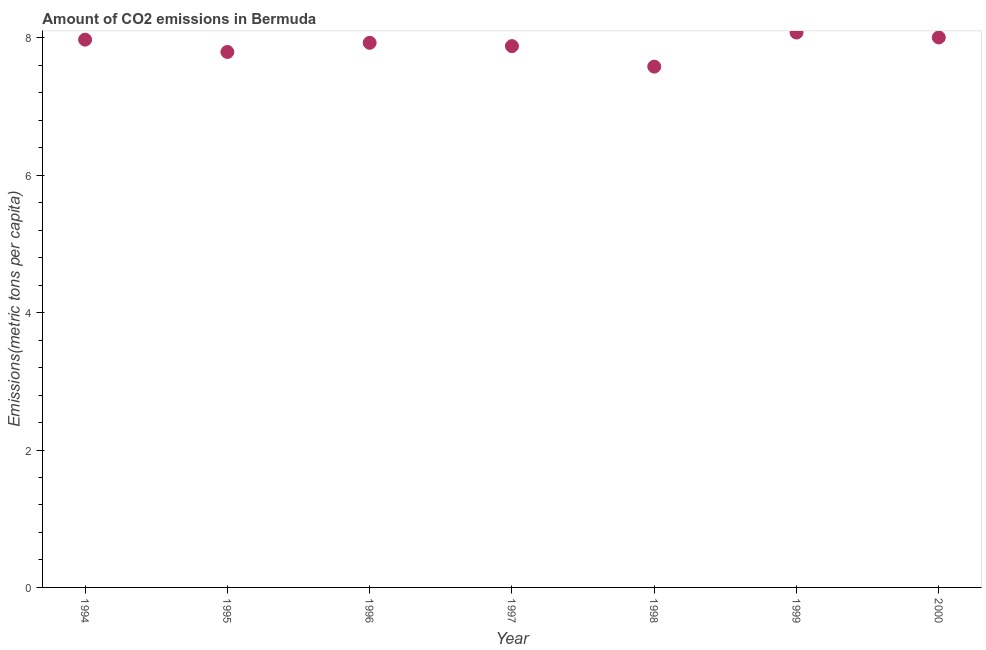What is the amount of co2 emissions in 1996?
Your response must be concise. 7.93. Across all years, what is the maximum amount of co2 emissions?
Provide a short and direct response. 8.08. Across all years, what is the minimum amount of co2 emissions?
Provide a succinct answer. 7.58. In which year was the amount of co2 emissions maximum?
Make the answer very short. 1999. What is the sum of the amount of co2 emissions?
Offer a terse response. 55.24. What is the difference between the amount of co2 emissions in 1998 and 2000?
Provide a succinct answer. -0.42. What is the average amount of co2 emissions per year?
Provide a succinct answer. 7.89. What is the median amount of co2 emissions?
Make the answer very short. 7.93. What is the ratio of the amount of co2 emissions in 1995 to that in 2000?
Keep it short and to the point. 0.97. What is the difference between the highest and the second highest amount of co2 emissions?
Your response must be concise. 0.07. Is the sum of the amount of co2 emissions in 1996 and 2000 greater than the maximum amount of co2 emissions across all years?
Give a very brief answer. Yes. What is the difference between the highest and the lowest amount of co2 emissions?
Keep it short and to the point. 0.5. Does the amount of co2 emissions monotonically increase over the years?
Ensure brevity in your answer.  No. How many years are there in the graph?
Provide a succinct answer. 7. Does the graph contain any zero values?
Give a very brief answer. No. What is the title of the graph?
Provide a short and direct response. Amount of CO2 emissions in Bermuda. What is the label or title of the Y-axis?
Your answer should be compact. Emissions(metric tons per capita). What is the Emissions(metric tons per capita) in 1994?
Make the answer very short. 7.97. What is the Emissions(metric tons per capita) in 1995?
Ensure brevity in your answer.  7.79. What is the Emissions(metric tons per capita) in 1996?
Provide a short and direct response. 7.93. What is the Emissions(metric tons per capita) in 1997?
Provide a succinct answer. 7.88. What is the Emissions(metric tons per capita) in 1998?
Provide a short and direct response. 7.58. What is the Emissions(metric tons per capita) in 1999?
Ensure brevity in your answer.  8.08. What is the Emissions(metric tons per capita) in 2000?
Ensure brevity in your answer.  8.01. What is the difference between the Emissions(metric tons per capita) in 1994 and 1995?
Give a very brief answer. 0.18. What is the difference between the Emissions(metric tons per capita) in 1994 and 1996?
Provide a short and direct response. 0.05. What is the difference between the Emissions(metric tons per capita) in 1994 and 1997?
Offer a very short reply. 0.09. What is the difference between the Emissions(metric tons per capita) in 1994 and 1998?
Offer a terse response. 0.39. What is the difference between the Emissions(metric tons per capita) in 1994 and 1999?
Make the answer very short. -0.1. What is the difference between the Emissions(metric tons per capita) in 1994 and 2000?
Offer a very short reply. -0.03. What is the difference between the Emissions(metric tons per capita) in 1995 and 1996?
Provide a short and direct response. -0.13. What is the difference between the Emissions(metric tons per capita) in 1995 and 1997?
Offer a terse response. -0.09. What is the difference between the Emissions(metric tons per capita) in 1995 and 1998?
Offer a terse response. 0.21. What is the difference between the Emissions(metric tons per capita) in 1995 and 1999?
Your answer should be compact. -0.28. What is the difference between the Emissions(metric tons per capita) in 1995 and 2000?
Keep it short and to the point. -0.21. What is the difference between the Emissions(metric tons per capita) in 1996 and 1997?
Give a very brief answer. 0.05. What is the difference between the Emissions(metric tons per capita) in 1996 and 1998?
Keep it short and to the point. 0.35. What is the difference between the Emissions(metric tons per capita) in 1996 and 1999?
Offer a terse response. -0.15. What is the difference between the Emissions(metric tons per capita) in 1996 and 2000?
Offer a very short reply. -0.08. What is the difference between the Emissions(metric tons per capita) in 1997 and 1998?
Your answer should be compact. 0.3. What is the difference between the Emissions(metric tons per capita) in 1997 and 1999?
Your answer should be compact. -0.2. What is the difference between the Emissions(metric tons per capita) in 1997 and 2000?
Ensure brevity in your answer.  -0.13. What is the difference between the Emissions(metric tons per capita) in 1998 and 1999?
Your response must be concise. -0.5. What is the difference between the Emissions(metric tons per capita) in 1998 and 2000?
Offer a terse response. -0.42. What is the difference between the Emissions(metric tons per capita) in 1999 and 2000?
Your answer should be compact. 0.07. What is the ratio of the Emissions(metric tons per capita) in 1994 to that in 1995?
Provide a succinct answer. 1.02. What is the ratio of the Emissions(metric tons per capita) in 1994 to that in 1996?
Keep it short and to the point. 1.01. What is the ratio of the Emissions(metric tons per capita) in 1994 to that in 1998?
Give a very brief answer. 1.05. What is the ratio of the Emissions(metric tons per capita) in 1994 to that in 2000?
Make the answer very short. 1. What is the ratio of the Emissions(metric tons per capita) in 1995 to that in 1998?
Offer a terse response. 1.03. What is the ratio of the Emissions(metric tons per capita) in 1996 to that in 1998?
Provide a succinct answer. 1.05. What is the ratio of the Emissions(metric tons per capita) in 1996 to that in 2000?
Provide a succinct answer. 0.99. What is the ratio of the Emissions(metric tons per capita) in 1997 to that in 1998?
Your answer should be compact. 1.04. What is the ratio of the Emissions(metric tons per capita) in 1997 to that in 2000?
Your response must be concise. 0.98. What is the ratio of the Emissions(metric tons per capita) in 1998 to that in 1999?
Your answer should be compact. 0.94. What is the ratio of the Emissions(metric tons per capita) in 1998 to that in 2000?
Make the answer very short. 0.95. What is the ratio of the Emissions(metric tons per capita) in 1999 to that in 2000?
Your answer should be very brief. 1.01. 